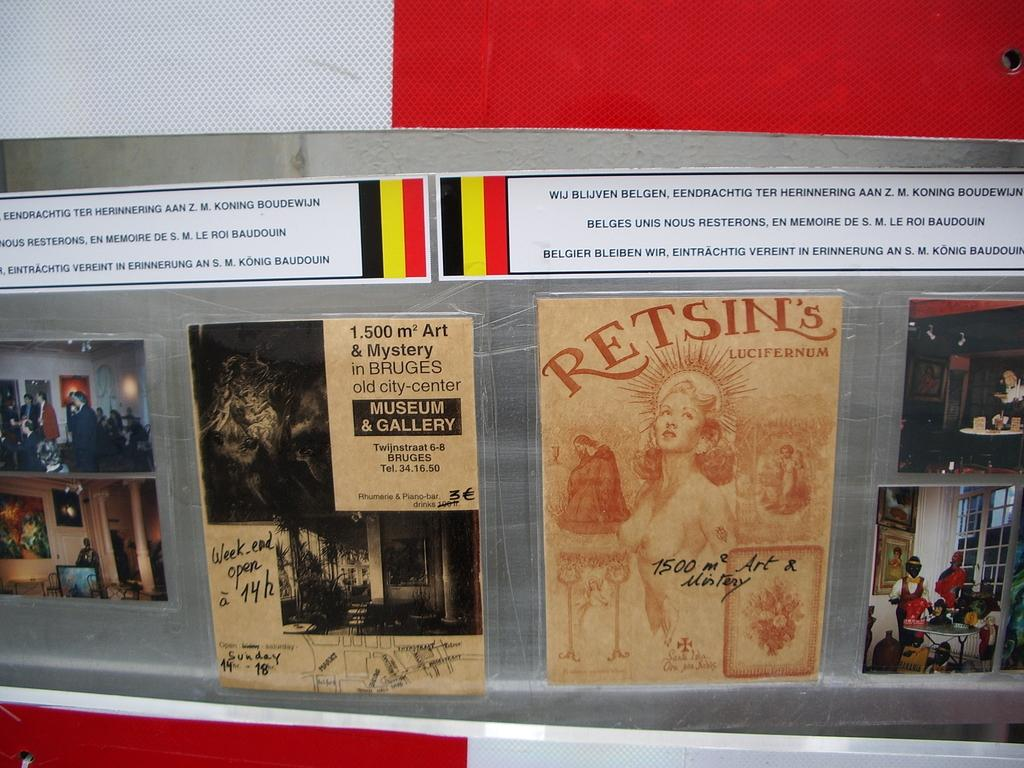What is hanging on the wall in the image? There are posters and photos on the wall. Can you describe the content of the posters and photos? Unfortunately, the specific content of the posters and photos cannot be determined from the provided facts. How many items are hanging on the wall? There are at least two items hanging on the wall, as there are both posters and photos present. Are there any bushes visible in the middle of the seashore in the image? There is no mention of bushes, a seashore, or a middle area in the provided facts, so it cannot be determined if they are present in the image. 